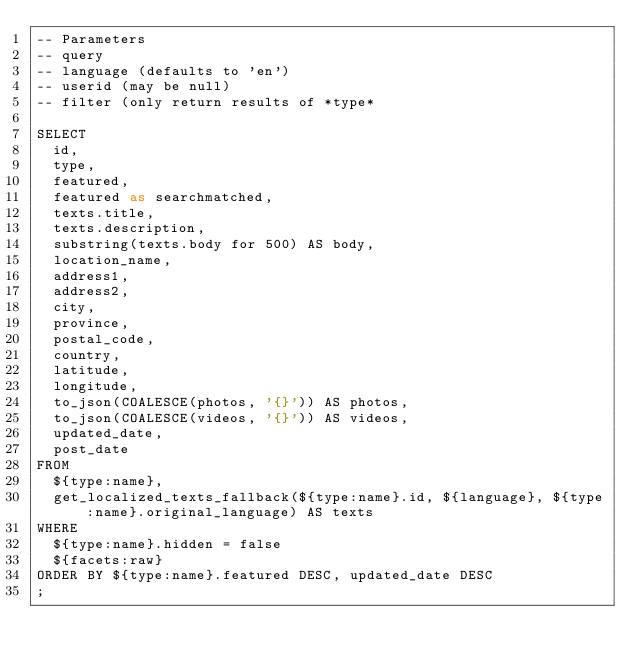<code> <loc_0><loc_0><loc_500><loc_500><_SQL_>-- Parameters
-- query
-- language (defaults to 'en')
-- userid (may be null)
-- filter (only return results of *type*

SELECT
  id,
  type,
  featured,
  featured as searchmatched,
  texts.title,
  texts.description,
  substring(texts.body for 500) AS body,
  location_name,
  address1,
  address2,
  city,
  province,
  postal_code,
  country,
  latitude,
  longitude,
  to_json(COALESCE(photos, '{}')) AS photos,
  to_json(COALESCE(videos, '{}')) AS videos,
  updated_date,
  post_date
FROM
  ${type:name},
  get_localized_texts_fallback(${type:name}.id, ${language}, ${type:name}.original_language) AS texts
WHERE
  ${type:name}.hidden = false
  ${facets:raw}
ORDER BY ${type:name}.featured DESC, updated_date DESC
;
</code> 